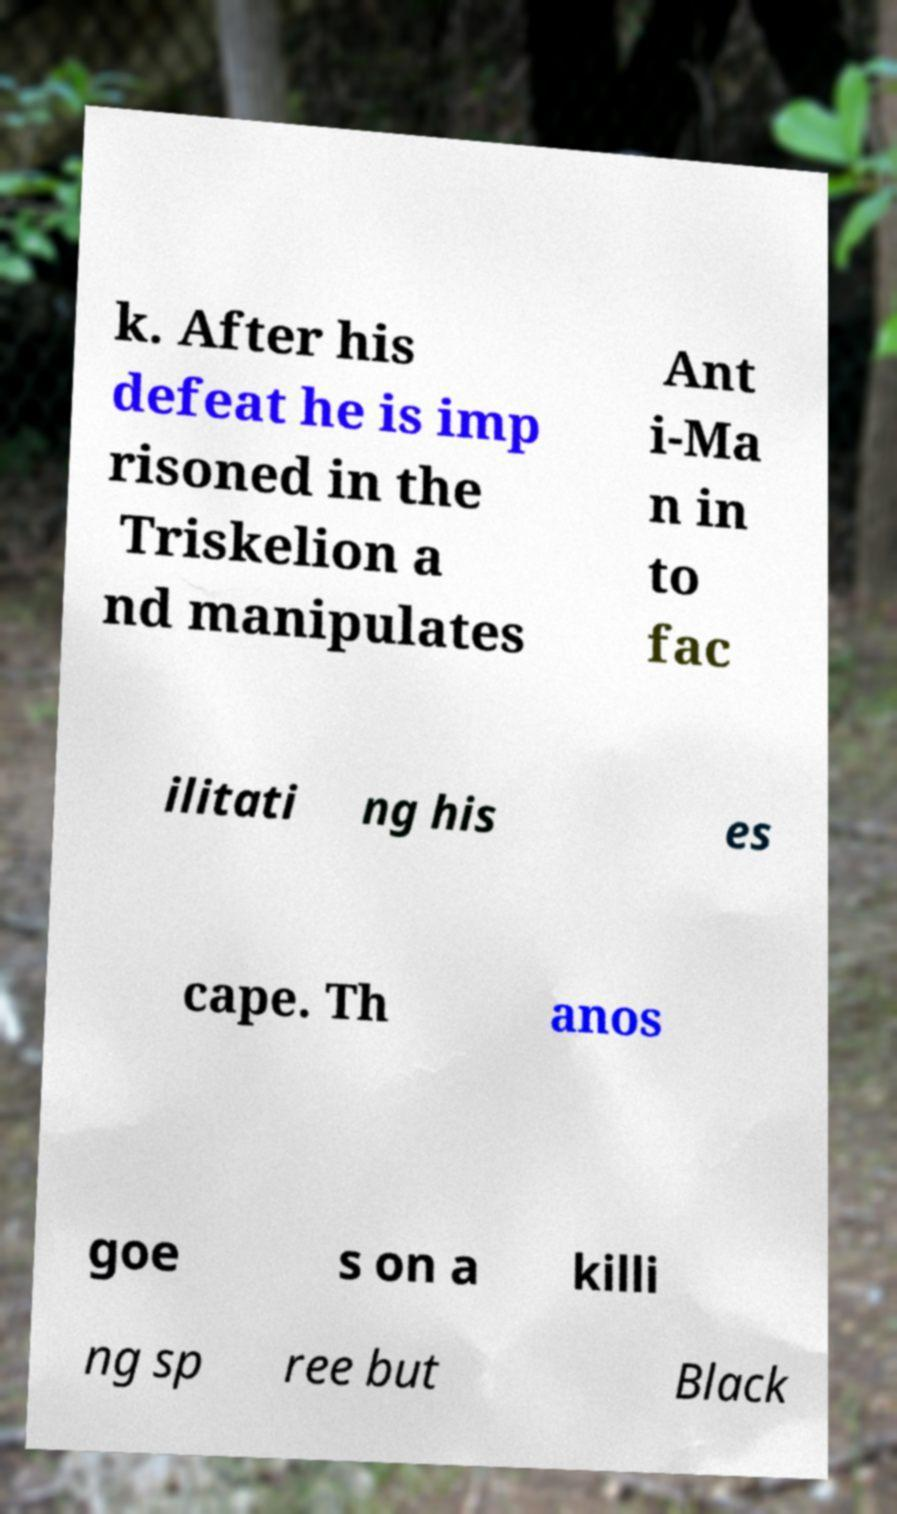There's text embedded in this image that I need extracted. Can you transcribe it verbatim? k. After his defeat he is imp risoned in the Triskelion a nd manipulates Ant i-Ma n in to fac ilitati ng his es cape. Th anos goe s on a killi ng sp ree but Black 